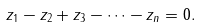Convert formula to latex. <formula><loc_0><loc_0><loc_500><loc_500>z _ { 1 } - z _ { 2 } + z _ { 3 } - \cdots - z _ { n } = 0 .</formula> 